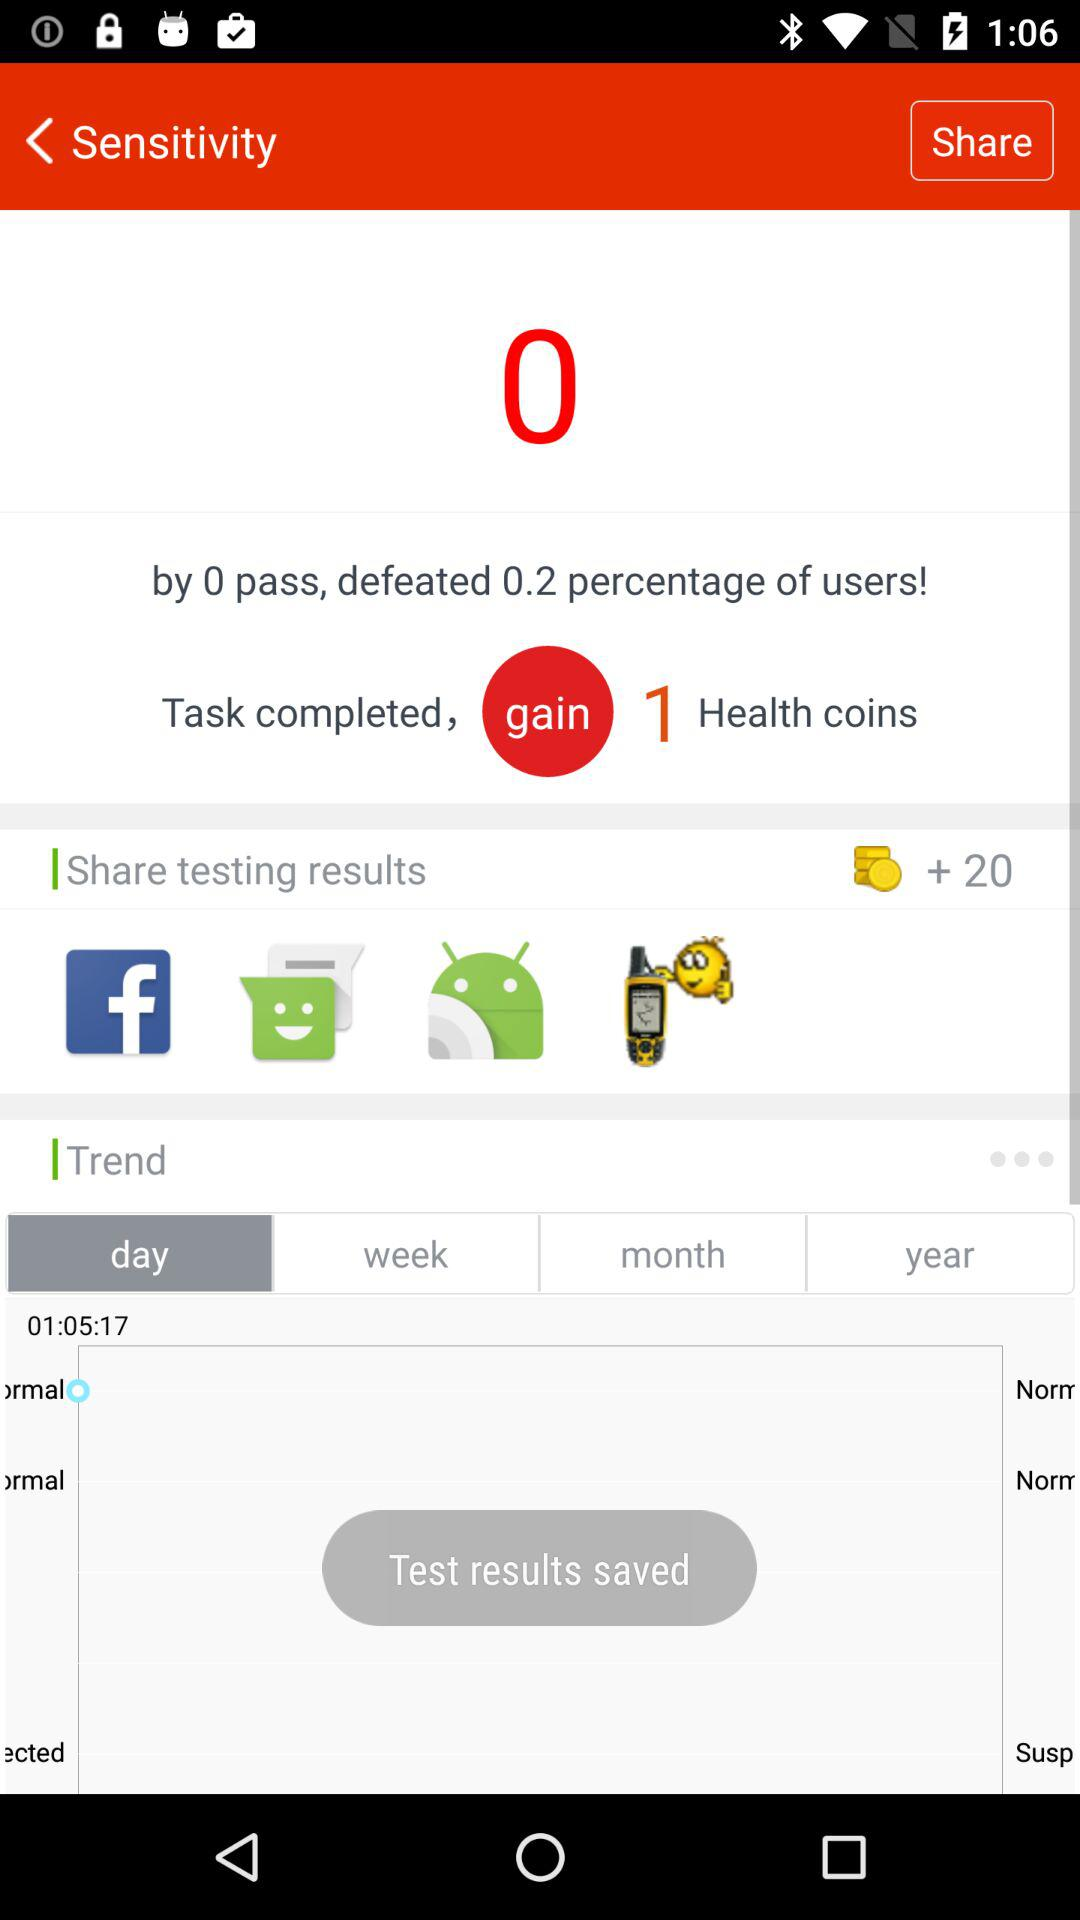How long did the user take to complete the task?
Answer the question using a single word or phrase. 01:05:17 